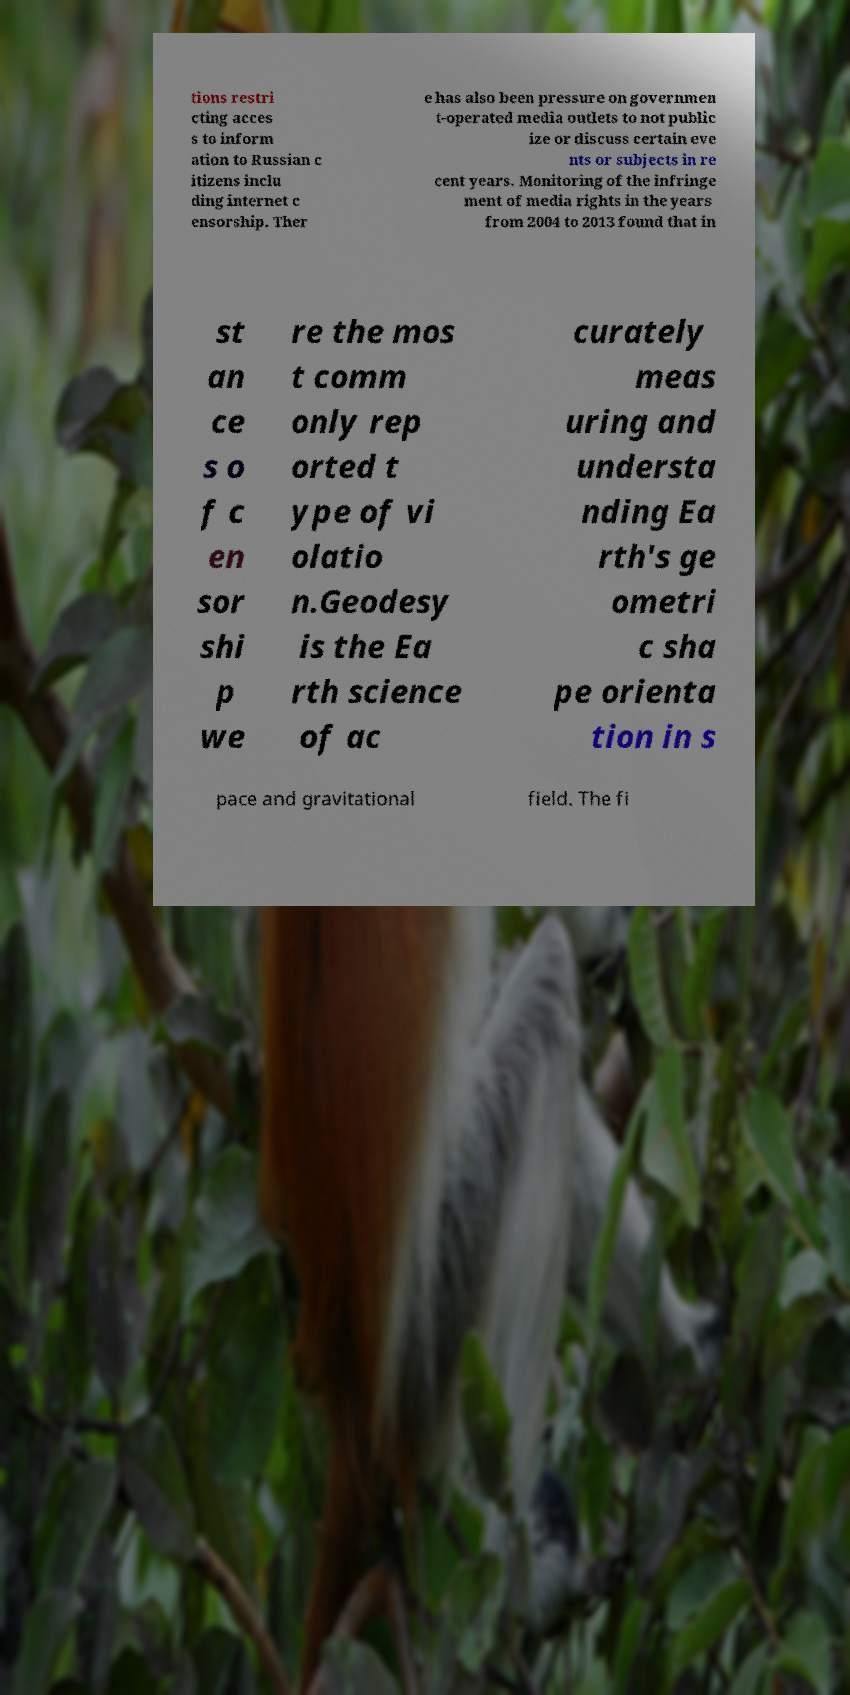Can you accurately transcribe the text from the provided image for me? tions restri cting acces s to inform ation to Russian c itizens inclu ding internet c ensorship. Ther e has also been pressure on governmen t-operated media outlets to not public ize or discuss certain eve nts or subjects in re cent years. Monitoring of the infringe ment of media rights in the years from 2004 to 2013 found that in st an ce s o f c en sor shi p we re the mos t comm only rep orted t ype of vi olatio n.Geodesy is the Ea rth science of ac curately meas uring and understa nding Ea rth's ge ometri c sha pe orienta tion in s pace and gravitational field. The fi 